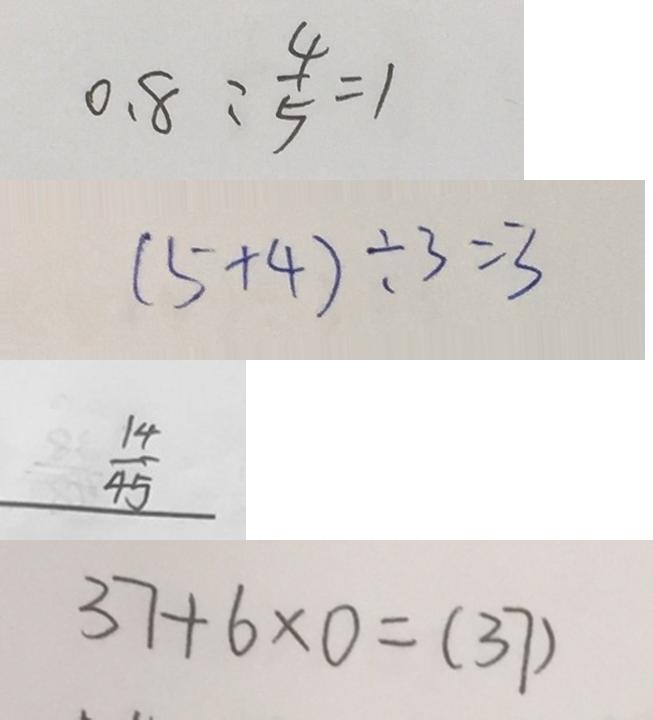Convert formula to latex. <formula><loc_0><loc_0><loc_500><loc_500>0 . 8 : \frac { 4 } { 5 } = 1 
 ( 5 + 4 ) \div 3 = 3 
 \frac { 1 4 } { 4 5 } 
 3 7 + 6 \times 0 = ( 3 7 )</formula> 